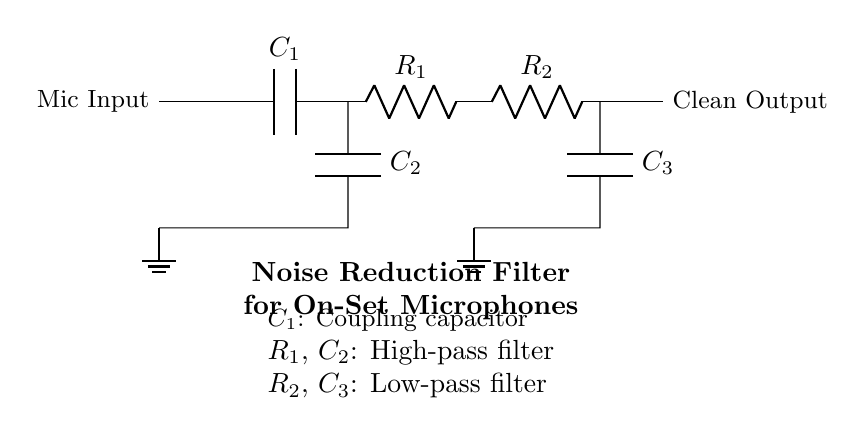What is the function of C1 in this circuit? C1 is a coupling capacitor used to block DC components while allowing AC signals (audio) to pass through.
Answer: Coupling capacitor What type of filter is formed by R1 and C2? R1 and C2 together create a high-pass filter, which allows signals above a certain frequency to pass while attenuating lower frequencies.
Answer: High-pass filter What is the purpose of R2 and C3 in the circuit? R2 and C3 form a low-pass filter that allows signals below a certain cutoff frequency to pass while reducing the amplitude of higher frequency sounds.
Answer: Low-pass filter How many capacitors are in the circuit? There are three capacitors in the circuit: C1, C2, and C3.
Answer: Three What is the output of the circuit labeled as? The output of the circuit is labeled as "Clean Output," indicating it's the processed audio signal.
Answer: Clean Output What is the role of the ground in this circuit? The ground serves as a reference point for the circuit's voltage levels and provides a return path for current, helping to stabilize the circuit.
Answer: Reference point What is the benefit of using high-pass and low-pass filters together in this circuit? Using both filters allows for effective noise reduction by eliminating unwanted low-frequency (like rumble) and high-frequency (like hiss) noises from the microphone input.
Answer: Effective noise reduction 